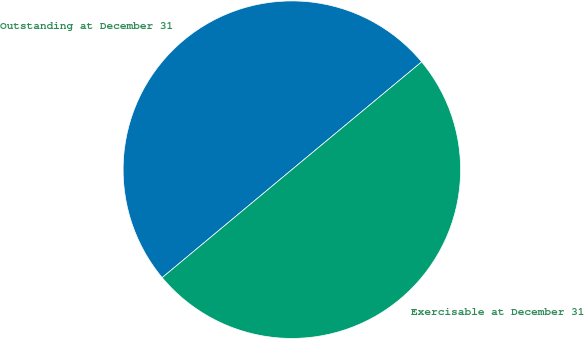Convert chart. <chart><loc_0><loc_0><loc_500><loc_500><pie_chart><fcel>Outstanding at December 31<fcel>Exercisable at December 31<nl><fcel>50.02%<fcel>49.98%<nl></chart> 